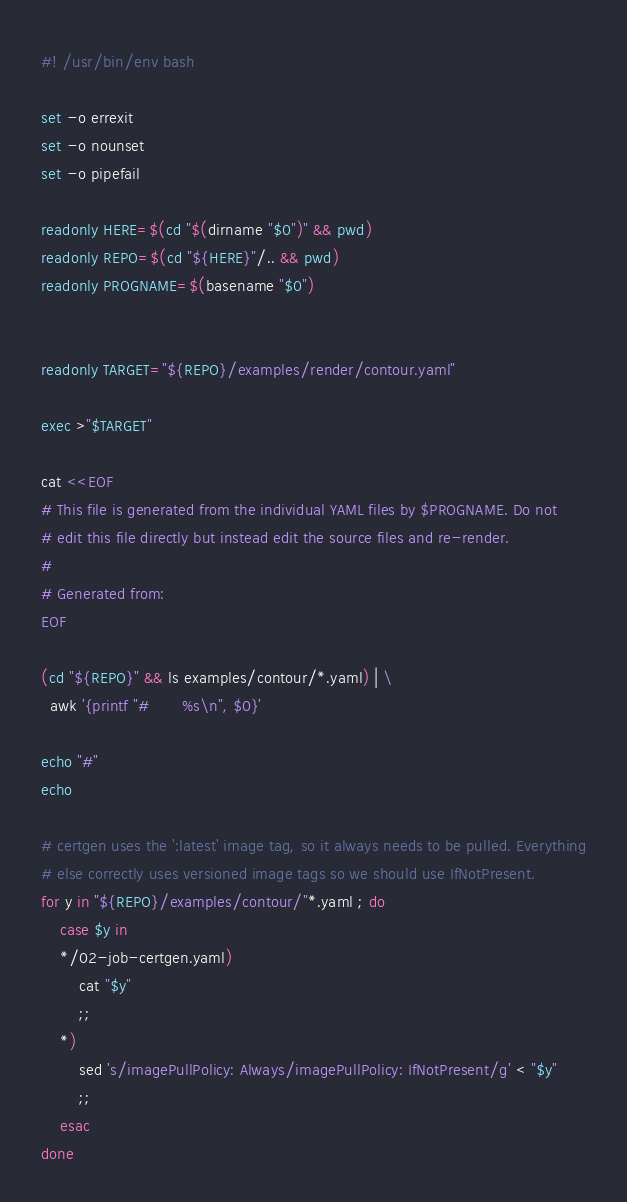Convert code to text. <code><loc_0><loc_0><loc_500><loc_500><_Bash_>#! /usr/bin/env bash

set -o errexit
set -o nounset
set -o pipefail

readonly HERE=$(cd "$(dirname "$0")" && pwd)
readonly REPO=$(cd "${HERE}"/.. && pwd)
readonly PROGNAME=$(basename "$0")


readonly TARGET="${REPO}/examples/render/contour.yaml"

exec >"$TARGET"

cat <<EOF
# This file is generated from the individual YAML files by $PROGNAME. Do not
# edit this file directly but instead edit the source files and re-render.
#
# Generated from:
EOF

(cd "${REPO}" && ls examples/contour/*.yaml) | \
  awk '{printf "#       %s\n", $0}'

echo "#"
echo

# certgen uses the ':latest' image tag, so it always needs to be pulled. Everything
# else correctly uses versioned image tags so we should use IfNotPresent.
for y in "${REPO}/examples/contour/"*.yaml ; do
    case $y in
    */02-job-certgen.yaml)
        cat "$y"
        ;;
    *)
        sed 's/imagePullPolicy: Always/imagePullPolicy: IfNotPresent/g' < "$y"
        ;;
    esac
done

</code> 